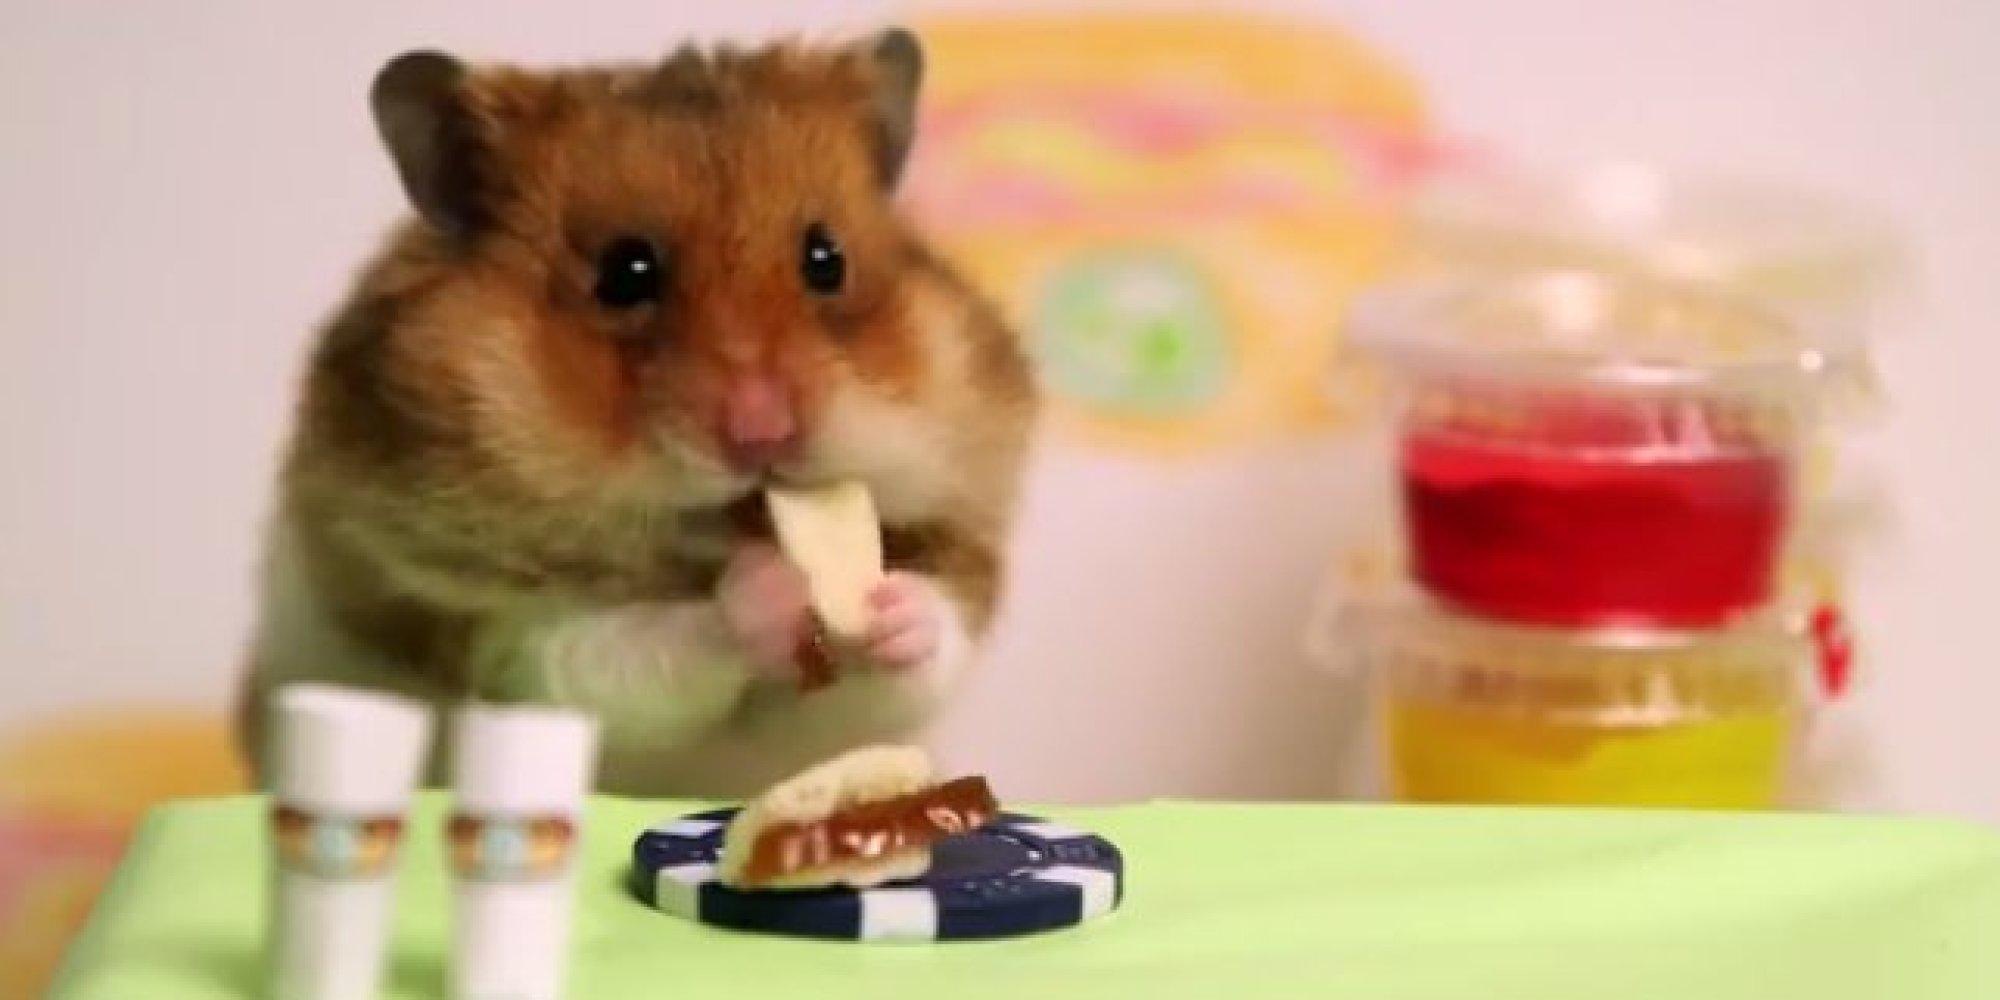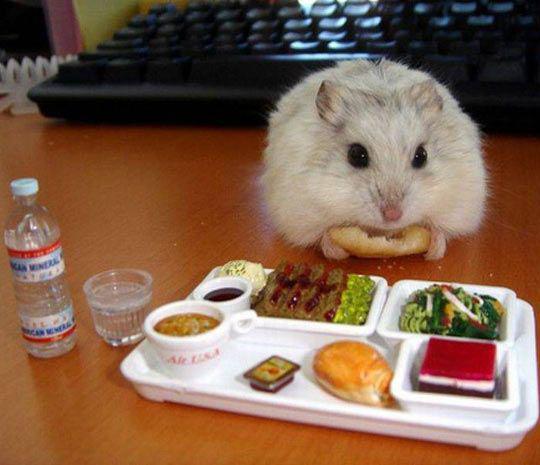The first image is the image on the left, the second image is the image on the right. For the images shown, is this caption "Some of these hamsters are eating """"people food""""." true? Answer yes or no. Yes. The first image is the image on the left, the second image is the image on the right. For the images shown, is this caption "One image shows a pet rodent standing on a bed of shredded material." true? Answer yes or no. No. 